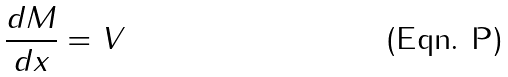Convert formula to latex. <formula><loc_0><loc_0><loc_500><loc_500>\frac { d M } { d x } = V</formula> 